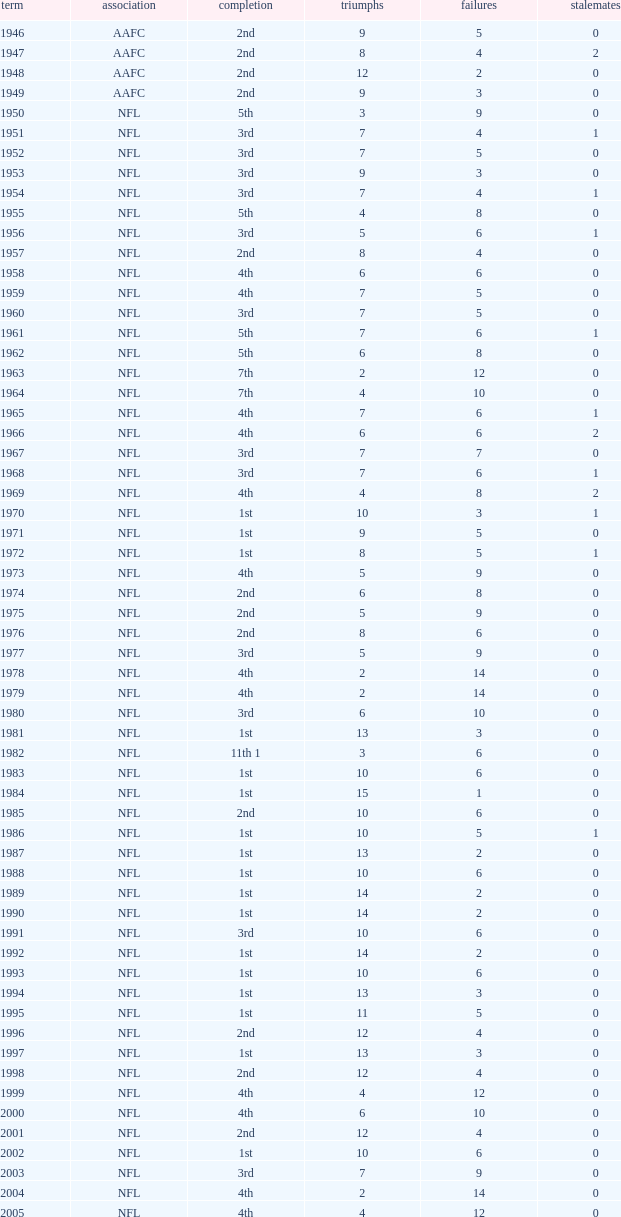What is the highest wins for the NFL with a finish of 1st, and more than 6 losses? None. 